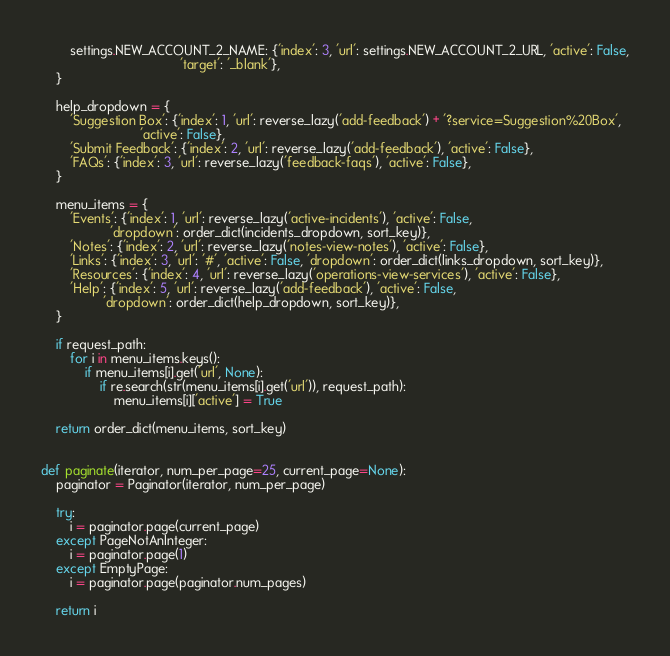<code> <loc_0><loc_0><loc_500><loc_500><_Python_>        settings.NEW_ACCOUNT_2_NAME: {'index': 3, 'url': settings.NEW_ACCOUNT_2_URL, 'active': False,
                                      'target': '_blank'},
    }

    help_dropdown = {
        'Suggestion Box': {'index': 1, 'url': reverse_lazy('add-feedback') + '?service=Suggestion%20Box',
                           'active': False},
        'Submit Feedback': {'index': 2, 'url': reverse_lazy('add-feedback'), 'active': False},
        'FAQs': {'index': 3, 'url': reverse_lazy('feedback-faqs'), 'active': False},
    }

    menu_items = {
        'Events': {'index': 1, 'url': reverse_lazy('active-incidents'), 'active': False,
                   'dropdown': order_dict(incidents_dropdown, sort_key)},
        'Notes': {'index': 2, 'url': reverse_lazy('notes-view-notes'), 'active': False},
        'Links': {'index': 3, 'url': '#', 'active': False, 'dropdown': order_dict(links_dropdown, sort_key)},
        'Resources': {'index': 4, 'url': reverse_lazy('operations-view-services'), 'active': False},
        'Help': {'index': 5, 'url': reverse_lazy('add-feedback'), 'active': False,
                 'dropdown': order_dict(help_dropdown, sort_key)},
    }

    if request_path:
        for i in menu_items.keys():
            if menu_items[i].get('url', None):
                if re.search(str(menu_items[i].get('url')), request_path):
                    menu_items[i]['active'] = True

    return order_dict(menu_items, sort_key)


def paginate(iterator, num_per_page=25, current_page=None):
    paginator = Paginator(iterator, num_per_page)

    try:
        i = paginator.page(current_page)
    except PageNotAnInteger:
        i = paginator.page(1)
    except EmptyPage:
        i = paginator.page(paginator.num_pages)

    return i
</code> 